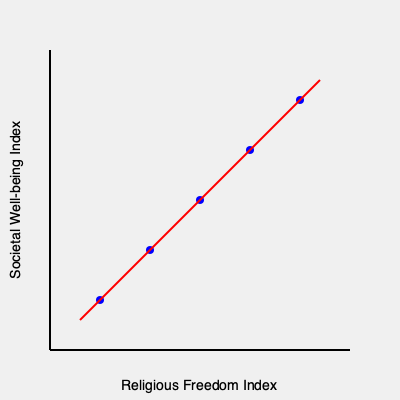Based on the scatter plot showing the relationship between religious freedom and societal well-being, what can be inferred about the correlation between these two variables? How might this information be used to advocate for religious freedom and individual spirituality? To answer this question, let's analyze the scatter plot step-by-step:

1. Observe the overall trend: The data points form a pattern moving from the bottom-left to the top-right of the graph.

2. Identify the variables:
   - X-axis: Religious Freedom Index
   - Y-axis: Societal Well-being Index

3. Interpret the correlation:
   - As the Religious Freedom Index increases, the Societal Well-being Index tends to increase as well.
   - This indicates a positive correlation between religious freedom and societal well-being.

4. Assess the strength of the correlation:
   - The data points are relatively close to the trend line (red line).
   - This suggests a strong positive correlation between the two variables.

5. Consider the implications:
   - Societies with higher religious freedom tend to have higher levels of well-being.
   - This could be due to factors such as reduced conflict, increased personal autonomy, and greater social harmony.

6. Application to advocacy:
   - This data can be used to argue that promoting religious freedom may lead to improved societal well-being.
   - It supports the idea that individual spirituality and freedom of belief contribute positively to society.
   - Policymakers could be encouraged to protect and enhance religious freedom to potentially improve overall societal well-being.

7. Limitations to consider:
   - Correlation does not imply causation; other factors may influence both variables.
   - The specific measures used for each index should be examined for validity and reliability.

In advocating for religious freedom and individual spirituality, this data can be presented as evidence that societies benefit from allowing diverse religious and spiritual practices, rather than imposing restrictions on belief systems.
Answer: Strong positive correlation between religious freedom and societal well-being, supporting advocacy for religious freedom and individual spirituality as potentially beneficial to society. 